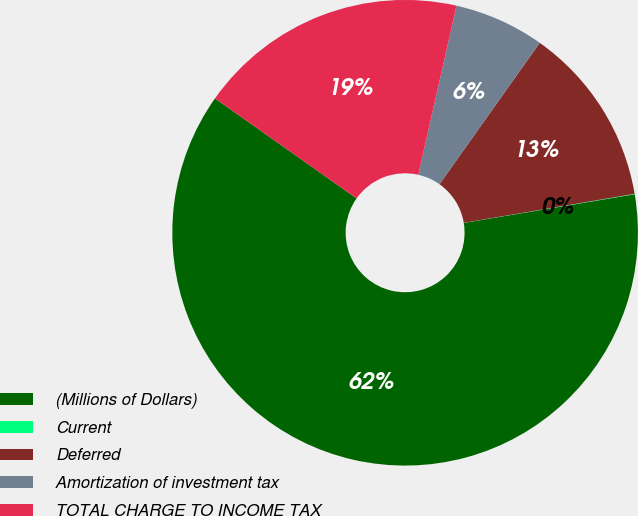Convert chart. <chart><loc_0><loc_0><loc_500><loc_500><pie_chart><fcel>(Millions of Dollars)<fcel>Current<fcel>Deferred<fcel>Amortization of investment tax<fcel>TOTAL CHARGE TO INCOME TAX<nl><fcel>62.43%<fcel>0.03%<fcel>12.51%<fcel>6.27%<fcel>18.75%<nl></chart> 